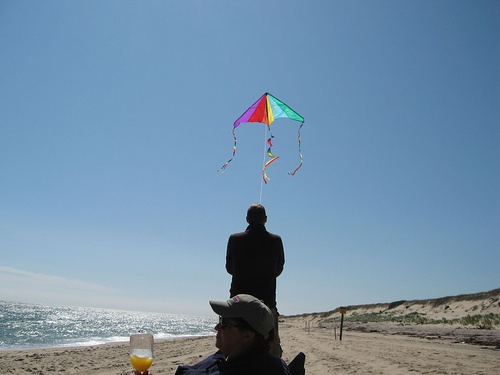Describe the objects in this image and their specific colors. I can see people in gray, black, and darkgray tones, people in gray, black, darkgray, and lightblue tones, kite in gray, brown, magenta, and lightblue tones, wine glass in gray, darkgray, and olive tones, and chair in gray and black tones in this image. 